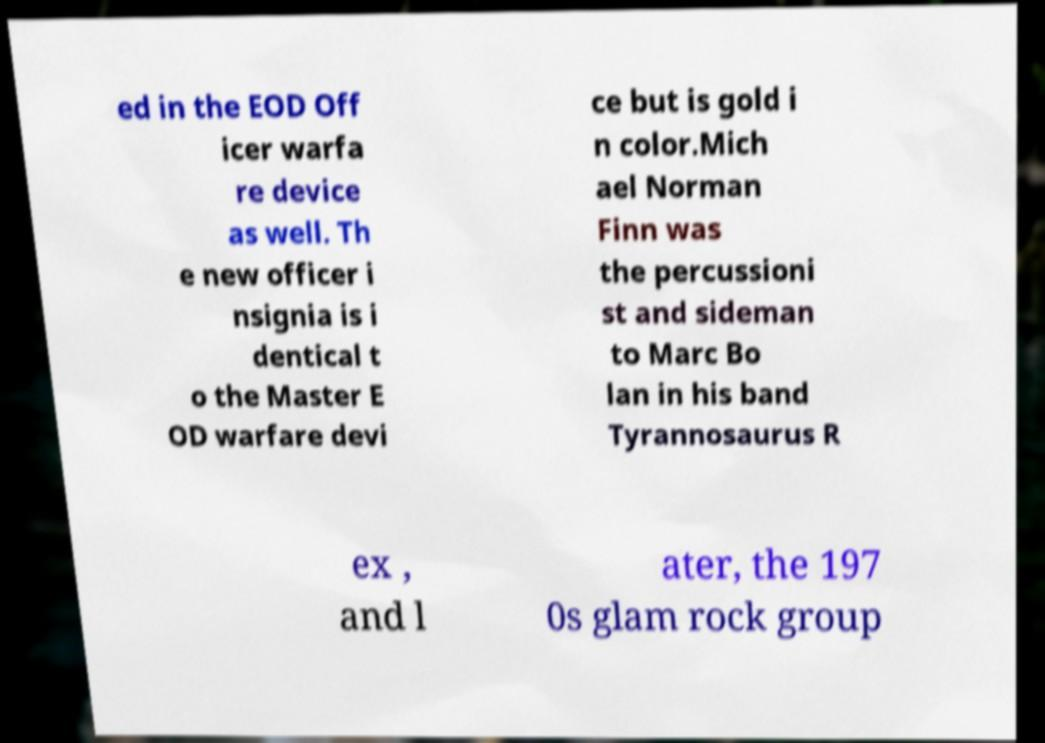Can you read and provide the text displayed in the image?This photo seems to have some interesting text. Can you extract and type it out for me? ed in the EOD Off icer warfa re device as well. Th e new officer i nsignia is i dentical t o the Master E OD warfare devi ce but is gold i n color.Mich ael Norman Finn was the percussioni st and sideman to Marc Bo lan in his band Tyrannosaurus R ex , and l ater, the 197 0s glam rock group 